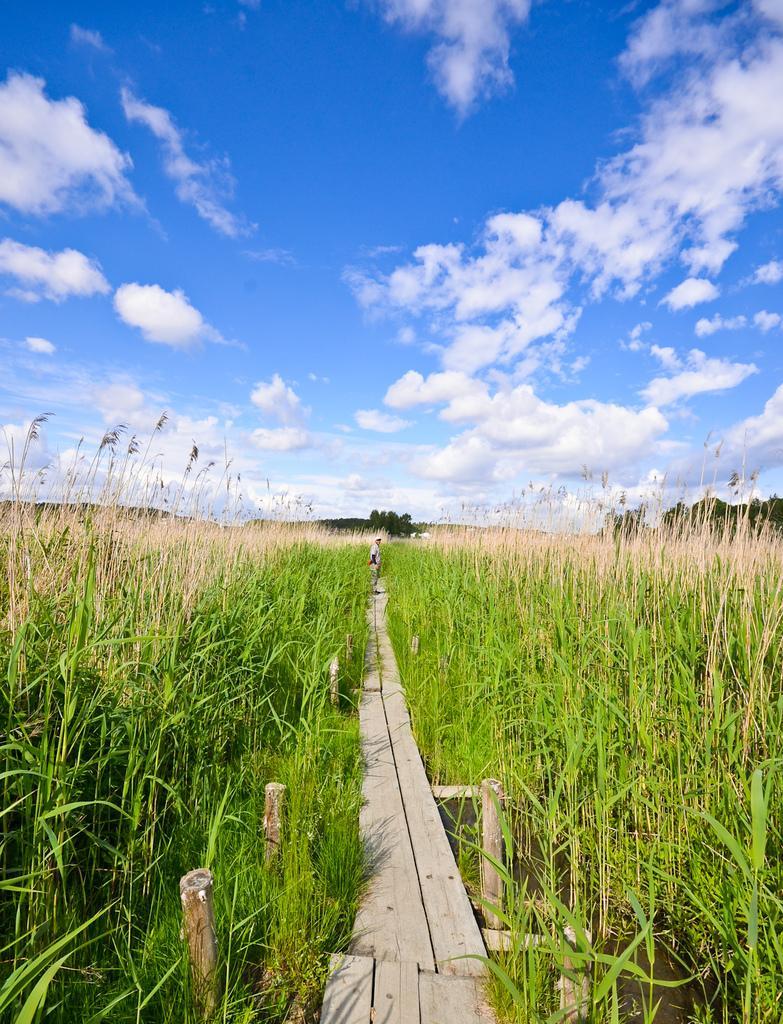Describe this image in one or two sentences. In this image, I think these are the crops. This is a wooden pathway. I can see a person standing. In the background, I can see the trees. These are the clouds in the sky. 